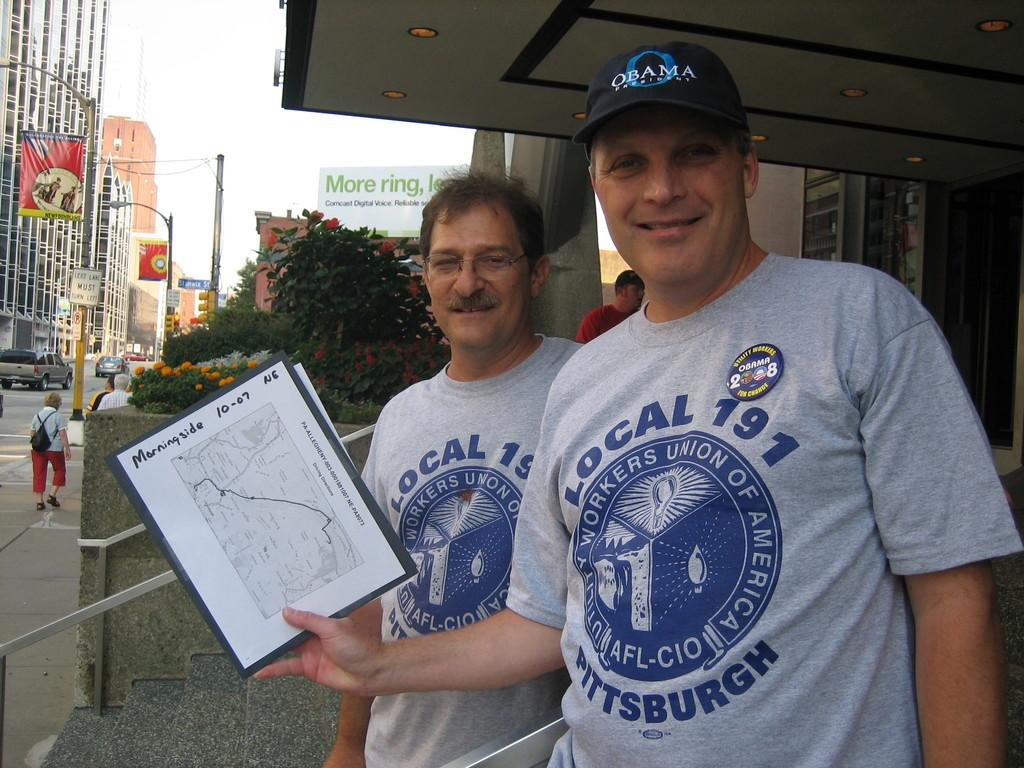<image>
Relay a brief, clear account of the picture shown. Two members of a local Pittsburgh union show a map of the Morningside neighborhood. 